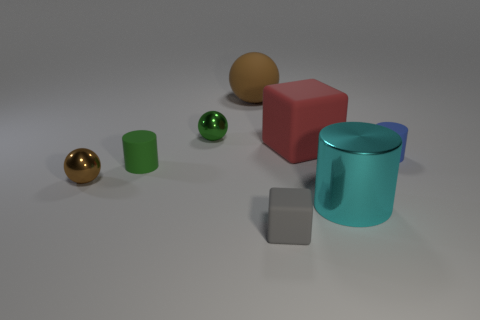Add 1 green metal blocks. How many objects exist? 9 Subtract all balls. How many objects are left? 5 Add 3 large metallic cylinders. How many large metallic cylinders are left? 4 Add 8 big gray objects. How many big gray objects exist? 8 Subtract 0 purple blocks. How many objects are left? 8 Subtract all tiny green matte objects. Subtract all large red rubber things. How many objects are left? 6 